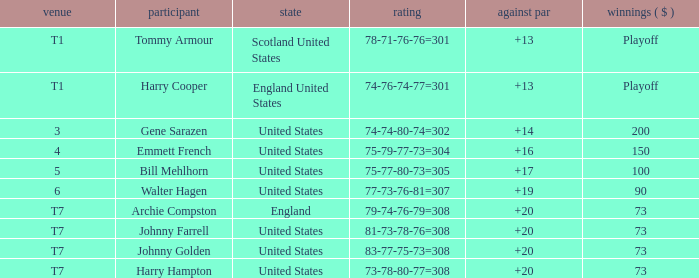What is the score for the United States when Harry Hampton is the player and the money is $73? 73-78-80-77=308. 